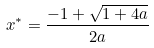<formula> <loc_0><loc_0><loc_500><loc_500>x ^ { * } = \frac { - 1 + \sqrt { 1 + 4 a } } { 2 a }</formula> 